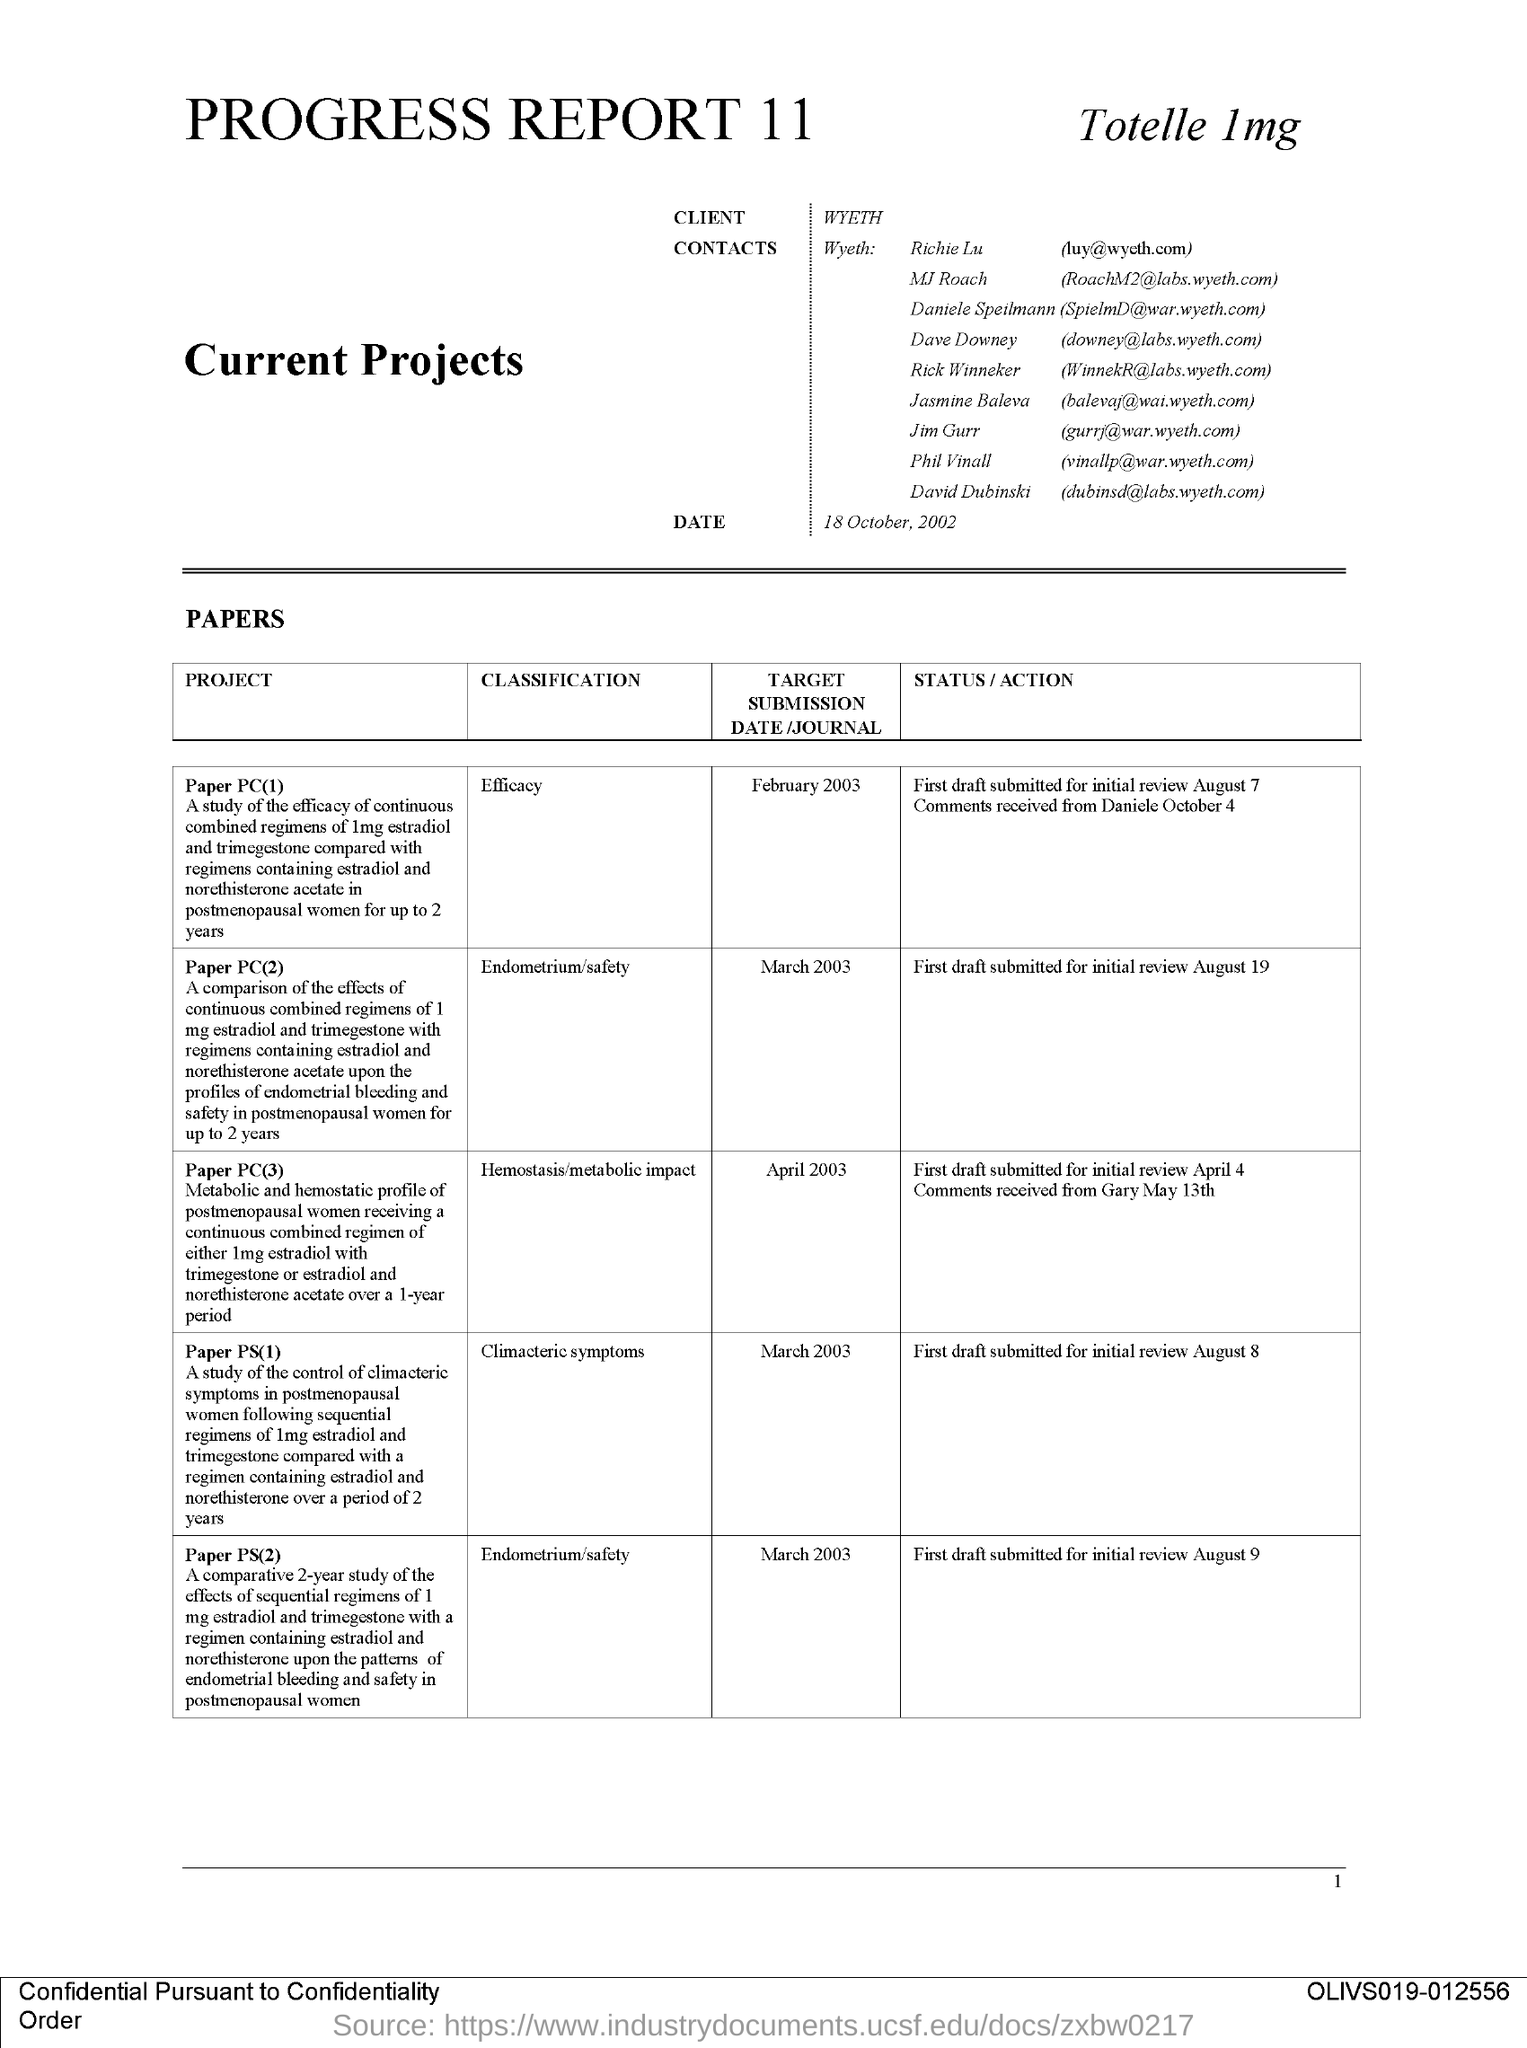Point out several critical features in this image. The project "Paper PC(2)" is classified as pertaining to the fields of endometrium and safety. The target submission date for the project "Paper PC(3)" is April 2003. The client mentioned in this document is Wyeth. The target submission date for the project "Paper PC(2)" is March 2003. The issued date of this document is 18 October, 2002. 